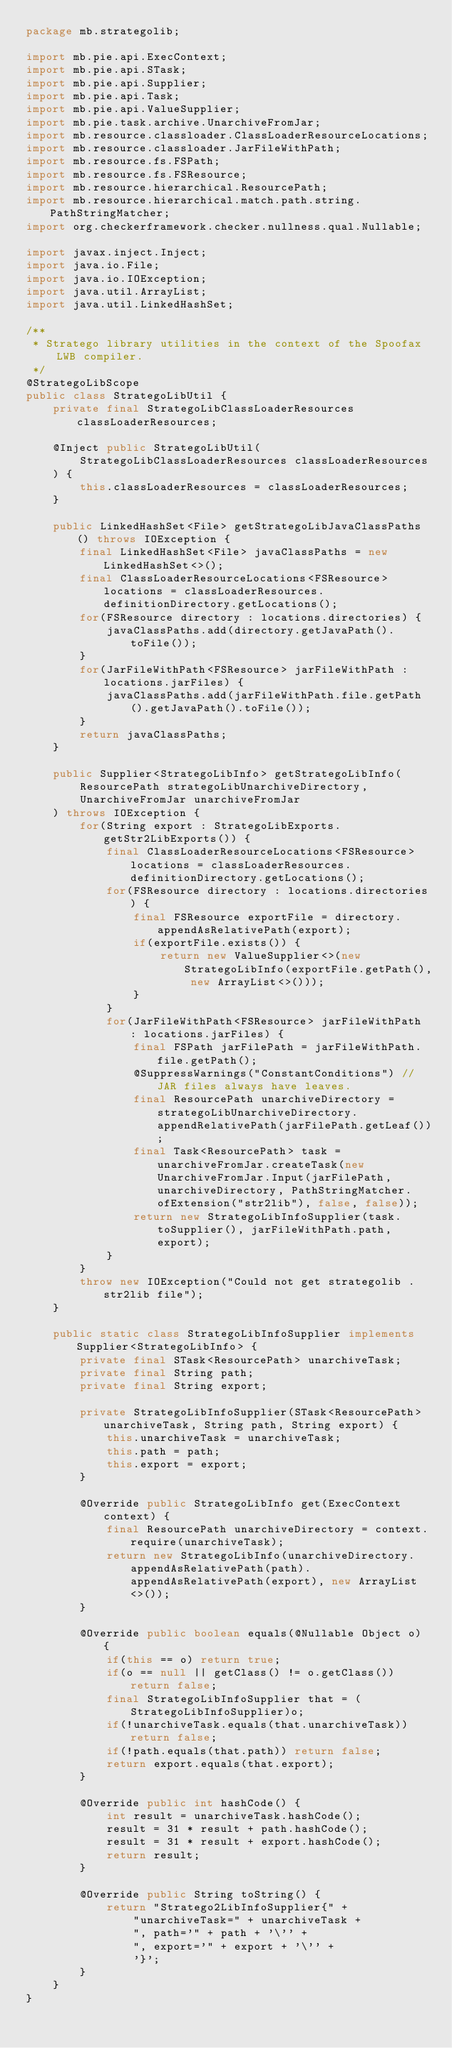<code> <loc_0><loc_0><loc_500><loc_500><_Java_>package mb.strategolib;

import mb.pie.api.ExecContext;
import mb.pie.api.STask;
import mb.pie.api.Supplier;
import mb.pie.api.Task;
import mb.pie.api.ValueSupplier;
import mb.pie.task.archive.UnarchiveFromJar;
import mb.resource.classloader.ClassLoaderResourceLocations;
import mb.resource.classloader.JarFileWithPath;
import mb.resource.fs.FSPath;
import mb.resource.fs.FSResource;
import mb.resource.hierarchical.ResourcePath;
import mb.resource.hierarchical.match.path.string.PathStringMatcher;
import org.checkerframework.checker.nullness.qual.Nullable;

import javax.inject.Inject;
import java.io.File;
import java.io.IOException;
import java.util.ArrayList;
import java.util.LinkedHashSet;

/**
 * Stratego library utilities in the context of the Spoofax LWB compiler.
 */
@StrategoLibScope
public class StrategoLibUtil {
    private final StrategoLibClassLoaderResources classLoaderResources;

    @Inject public StrategoLibUtil(
        StrategoLibClassLoaderResources classLoaderResources
    ) {
        this.classLoaderResources = classLoaderResources;
    }

    public LinkedHashSet<File> getStrategoLibJavaClassPaths() throws IOException {
        final LinkedHashSet<File> javaClassPaths = new LinkedHashSet<>();
        final ClassLoaderResourceLocations<FSResource> locations = classLoaderResources.definitionDirectory.getLocations();
        for(FSResource directory : locations.directories) {
            javaClassPaths.add(directory.getJavaPath().toFile());
        }
        for(JarFileWithPath<FSResource> jarFileWithPath : locations.jarFiles) {
            javaClassPaths.add(jarFileWithPath.file.getPath().getJavaPath().toFile());
        }
        return javaClassPaths;
    }

    public Supplier<StrategoLibInfo> getStrategoLibInfo(
        ResourcePath strategoLibUnarchiveDirectory,
        UnarchiveFromJar unarchiveFromJar
    ) throws IOException {
        for(String export : StrategoLibExports.getStr2LibExports()) {
            final ClassLoaderResourceLocations<FSResource> locations = classLoaderResources.definitionDirectory.getLocations();
            for(FSResource directory : locations.directories) {
                final FSResource exportFile = directory.appendAsRelativePath(export);
                if(exportFile.exists()) {
                    return new ValueSupplier<>(new StrategoLibInfo(exportFile.getPath(), new ArrayList<>()));
                }
            }
            for(JarFileWithPath<FSResource> jarFileWithPath : locations.jarFiles) {
                final FSPath jarFilePath = jarFileWithPath.file.getPath();
                @SuppressWarnings("ConstantConditions") // JAR files always have leaves.
                final ResourcePath unarchiveDirectory = strategoLibUnarchiveDirectory.appendRelativePath(jarFilePath.getLeaf());
                final Task<ResourcePath> task = unarchiveFromJar.createTask(new UnarchiveFromJar.Input(jarFilePath, unarchiveDirectory, PathStringMatcher.ofExtension("str2lib"), false, false));
                return new StrategoLibInfoSupplier(task.toSupplier(), jarFileWithPath.path, export);
            }
        }
        throw new IOException("Could not get strategolib .str2lib file");
    }

    public static class StrategoLibInfoSupplier implements Supplier<StrategoLibInfo> {
        private final STask<ResourcePath> unarchiveTask;
        private final String path;
        private final String export;

        private StrategoLibInfoSupplier(STask<ResourcePath> unarchiveTask, String path, String export) {
            this.unarchiveTask = unarchiveTask;
            this.path = path;
            this.export = export;
        }

        @Override public StrategoLibInfo get(ExecContext context) {
            final ResourcePath unarchiveDirectory = context.require(unarchiveTask);
            return new StrategoLibInfo(unarchiveDirectory.appendAsRelativePath(path).appendAsRelativePath(export), new ArrayList<>());
        }

        @Override public boolean equals(@Nullable Object o) {
            if(this == o) return true;
            if(o == null || getClass() != o.getClass()) return false;
            final StrategoLibInfoSupplier that = (StrategoLibInfoSupplier)o;
            if(!unarchiveTask.equals(that.unarchiveTask)) return false;
            if(!path.equals(that.path)) return false;
            return export.equals(that.export);
        }

        @Override public int hashCode() {
            int result = unarchiveTask.hashCode();
            result = 31 * result + path.hashCode();
            result = 31 * result + export.hashCode();
            return result;
        }

        @Override public String toString() {
            return "Stratego2LibInfoSupplier{" +
                "unarchiveTask=" + unarchiveTask +
                ", path='" + path + '\'' +
                ", export='" + export + '\'' +
                '}';
        }
    }
}
</code> 